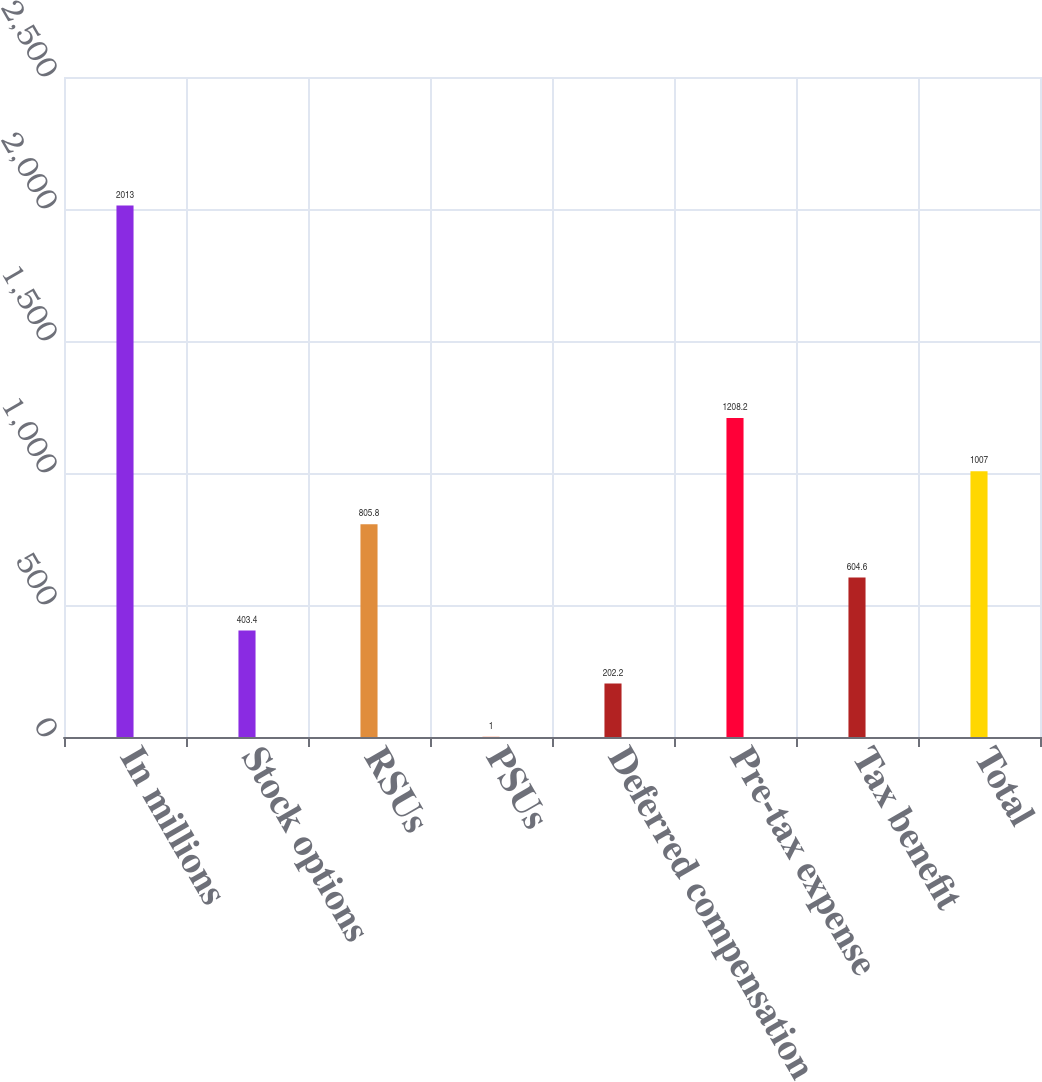Convert chart. <chart><loc_0><loc_0><loc_500><loc_500><bar_chart><fcel>In millions<fcel>Stock options<fcel>RSUs<fcel>PSUs<fcel>Deferred compensation<fcel>Pre-tax expense<fcel>Tax benefit<fcel>Total<nl><fcel>2013<fcel>403.4<fcel>805.8<fcel>1<fcel>202.2<fcel>1208.2<fcel>604.6<fcel>1007<nl></chart> 